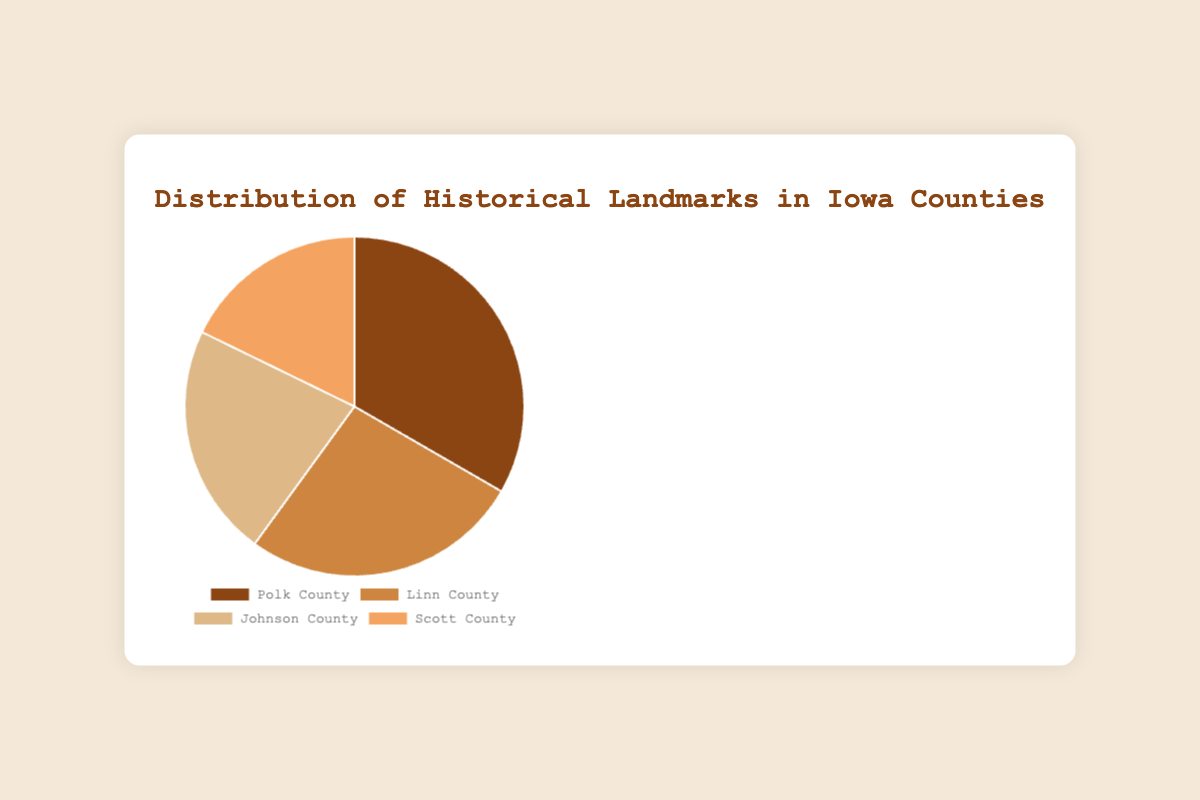What is the total number of historical landmarks in all counties? Sum the landmarks in each county: Polk (15) + Linn (12) + Johnson (10) + Scott (8) = 45 landmarks.
Answer: 45 Which county has the most historical landmarks? From the data provided, Polk County has the highest number of landmarks at 15.
Answer: Polk County How many more landmarks does Polk County have compared to Scott County? Subtract the number of landmarks in Scott County (8) from the number in Polk County (15): 15 - 8 = 7 landmarks more.
Answer: 7 What is the difference between the county with the most landmarks and the county with the least landmarks? Polk County has the most landmarks (15), and Scott County has the least (8). The difference is 15 - 8 = 7 landmarks.
Answer: 7 What is the average number of historical landmarks per county? Sum the landmarks: 15 + 12 + 10 + 8 = 45. Divide by the number of counties (4): 45 / 4 = 11.25 landmarks on average.
Answer: 11.25 Which county accounts for the smallest proportion of the historical landmarks? Scott County accounts for 8 out of 45 landmarks, which is the smallest count amongst the counties.
Answer: Scott County How many counties have more than 10 historical landmarks? Polk County (15) and Linn County (12) both have more than 10 landmarks. Therefore, 2 counties meet this criterion.
Answer: 2 If you were to visit one more historical landmark in each county, what would the new total be? Increase each county's landmarks count by 1: Polk (16), Linn (13), Johnson (11), Scott (9). Sum: 16 + 13 + 11 + 9 = 49 landmarks.
Answer: 49 